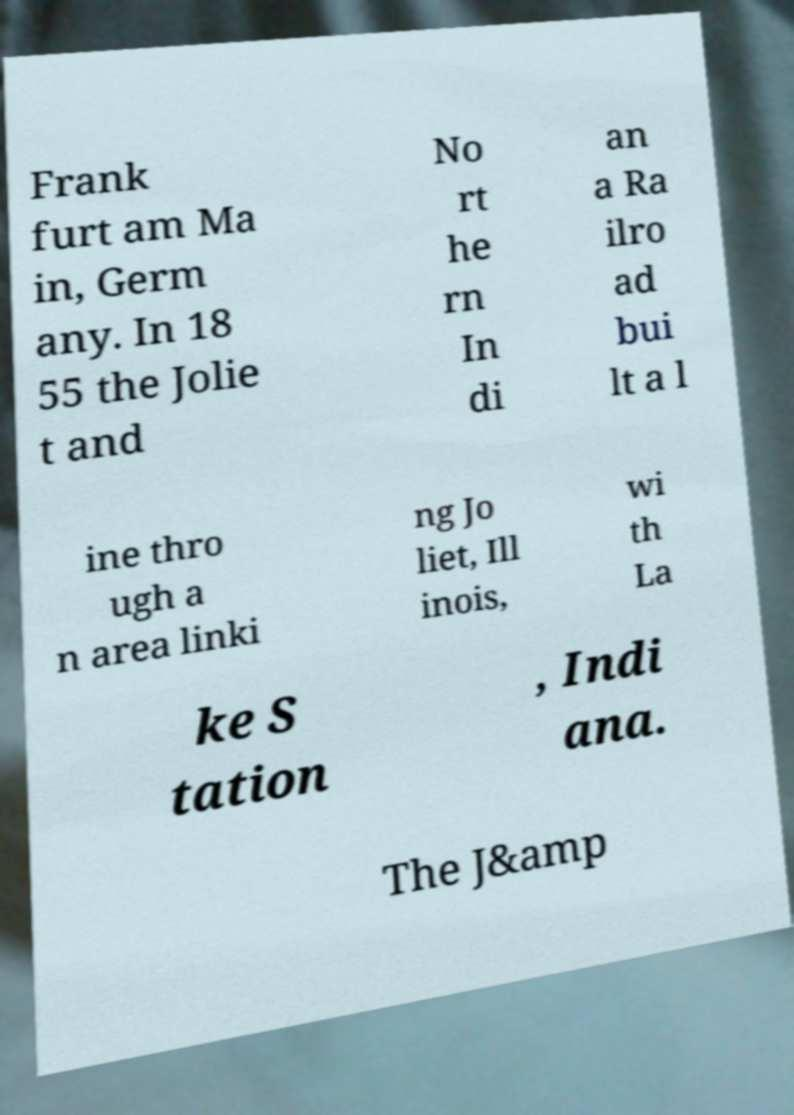Could you assist in decoding the text presented in this image and type it out clearly? Frank furt am Ma in, Germ any. In 18 55 the Jolie t and No rt he rn In di an a Ra ilro ad bui lt a l ine thro ugh a n area linki ng Jo liet, Ill inois, wi th La ke S tation , Indi ana. The J&amp 